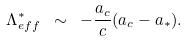<formula> <loc_0><loc_0><loc_500><loc_500>\Lambda ^ { \ast } _ { e f f } \ \sim \ - \frac { a _ { c } } { c } ( a _ { c } - a _ { \ast } ) .</formula> 